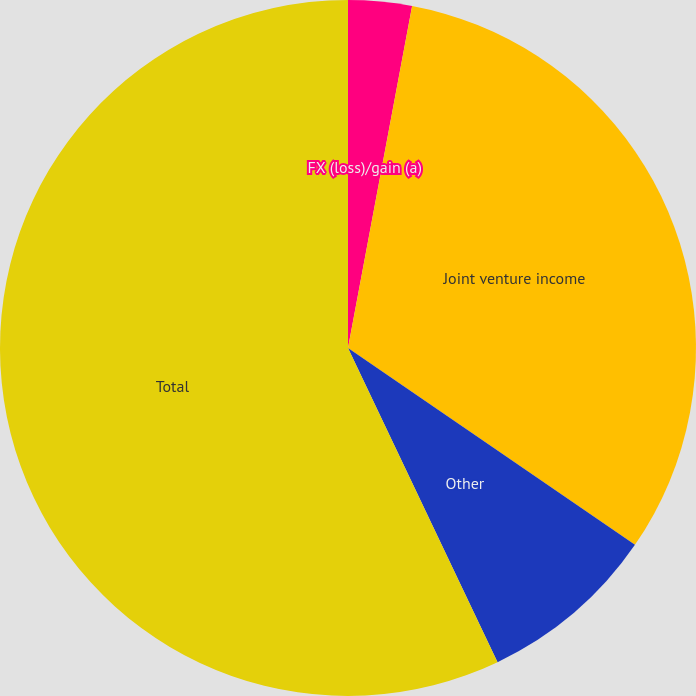<chart> <loc_0><loc_0><loc_500><loc_500><pie_chart><fcel>FX (loss)/gain (a)<fcel>Joint venture income<fcel>Other<fcel>Total<nl><fcel>2.95%<fcel>31.62%<fcel>8.36%<fcel>57.07%<nl></chart> 